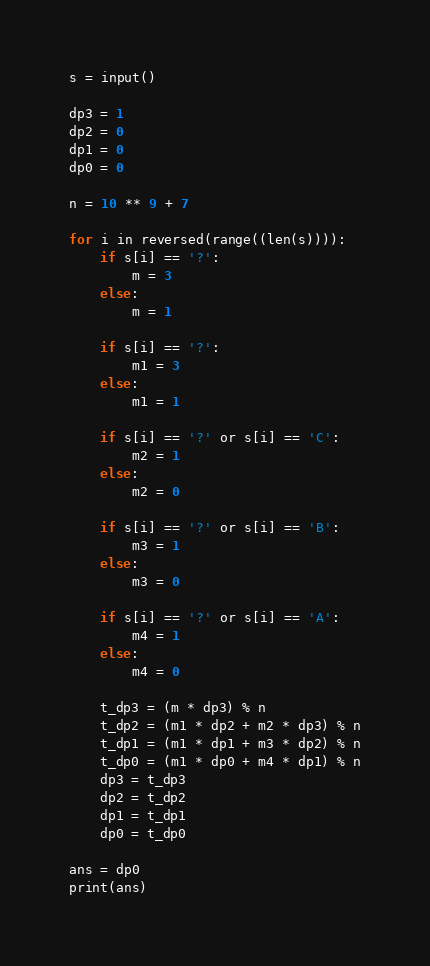Convert code to text. <code><loc_0><loc_0><loc_500><loc_500><_Python_>s = input()

dp3 = 1
dp2 = 0
dp1 = 0
dp0 = 0

n = 10 ** 9 + 7

for i in reversed(range((len(s)))):
    if s[i] == '?':
        m = 3
    else:
        m = 1

    if s[i] == '?':
        m1 = 3
    else:
        m1 = 1

    if s[i] == '?' or s[i] == 'C':
        m2 = 1
    else:
        m2 = 0

    if s[i] == '?' or s[i] == 'B':
        m3 = 1
    else:
        m3 = 0

    if s[i] == '?' or s[i] == 'A':
        m4 = 1
    else:
        m4 = 0

    t_dp3 = (m * dp3) % n
    t_dp2 = (m1 * dp2 + m2 * dp3) % n
    t_dp1 = (m1 * dp1 + m3 * dp2) % n
    t_dp0 = (m1 * dp0 + m4 * dp1) % n
    dp3 = t_dp3
    dp2 = t_dp2
    dp1 = t_dp1
    dp0 = t_dp0

ans = dp0
print(ans)</code> 